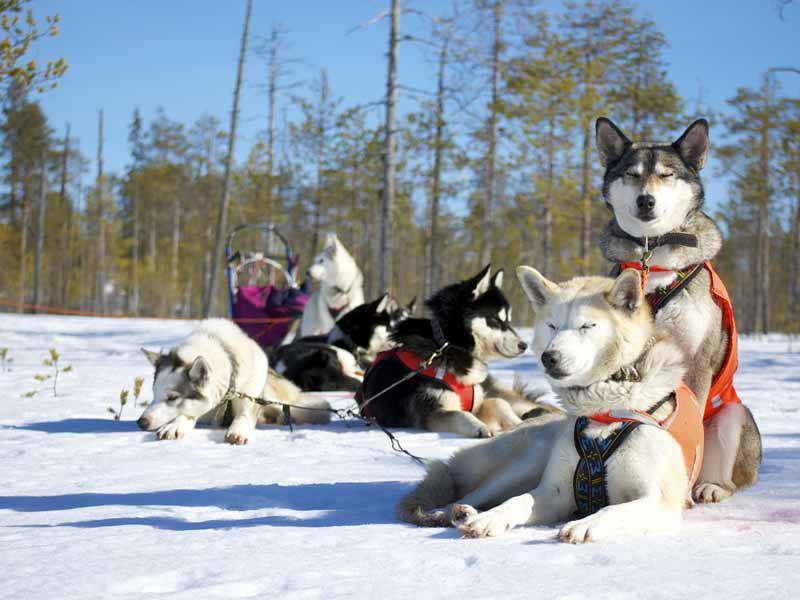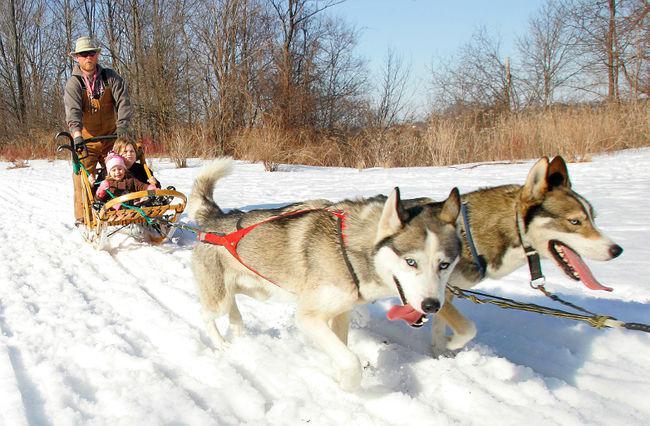The first image is the image on the left, the second image is the image on the right. For the images shown, is this caption "There are two huskies strapped next to each other on the snow." true? Answer yes or no. Yes. The first image is the image on the left, the second image is the image on the right. For the images shown, is this caption "In the right image, crowds of people are standing behind a dog sled team driven by a man in a vest and headed forward." true? Answer yes or no. No. 